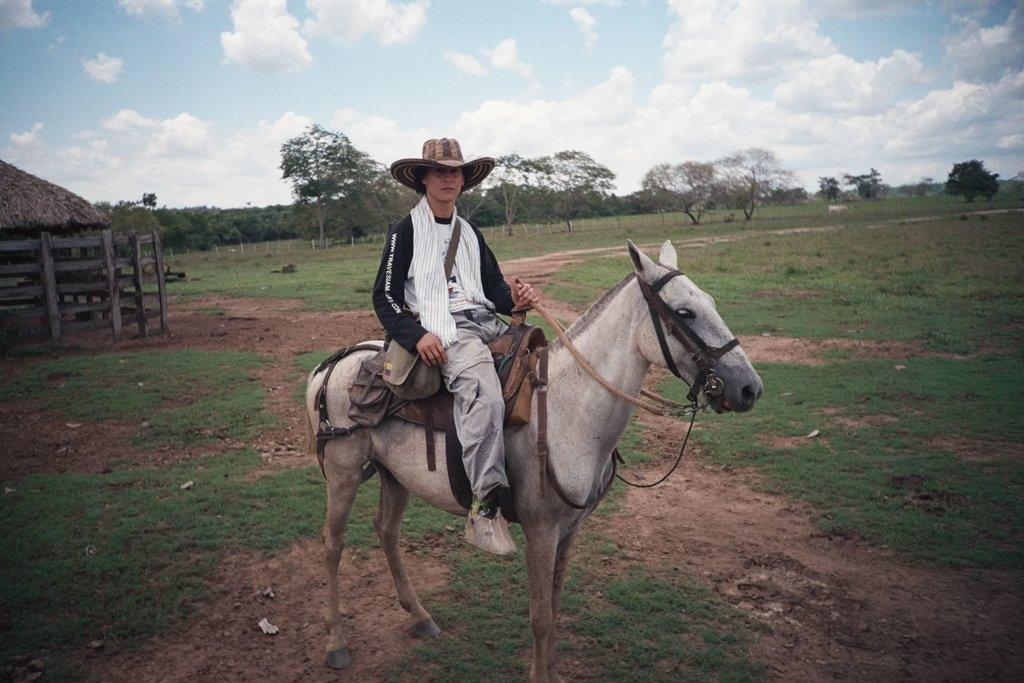What is the main subject of the image? The main subject of the image is a man. What is the man doing in the image? The man is sitting on a horse in the image. Where is the horse and man located in the image? The horse and man are in the middle of the image. What can be seen in the background of the image? There are trees in the background of the image. What is visible at the top of the image? The sky is visible at the top of the image. What type of fruit is the man holding in the image? There is no fruit present in the image; the man is sitting on a horse. Can you tell me how many people the man is talking to in the image? There is no indication of the man talking to anyone in the image; he is simply sitting on a horse. 